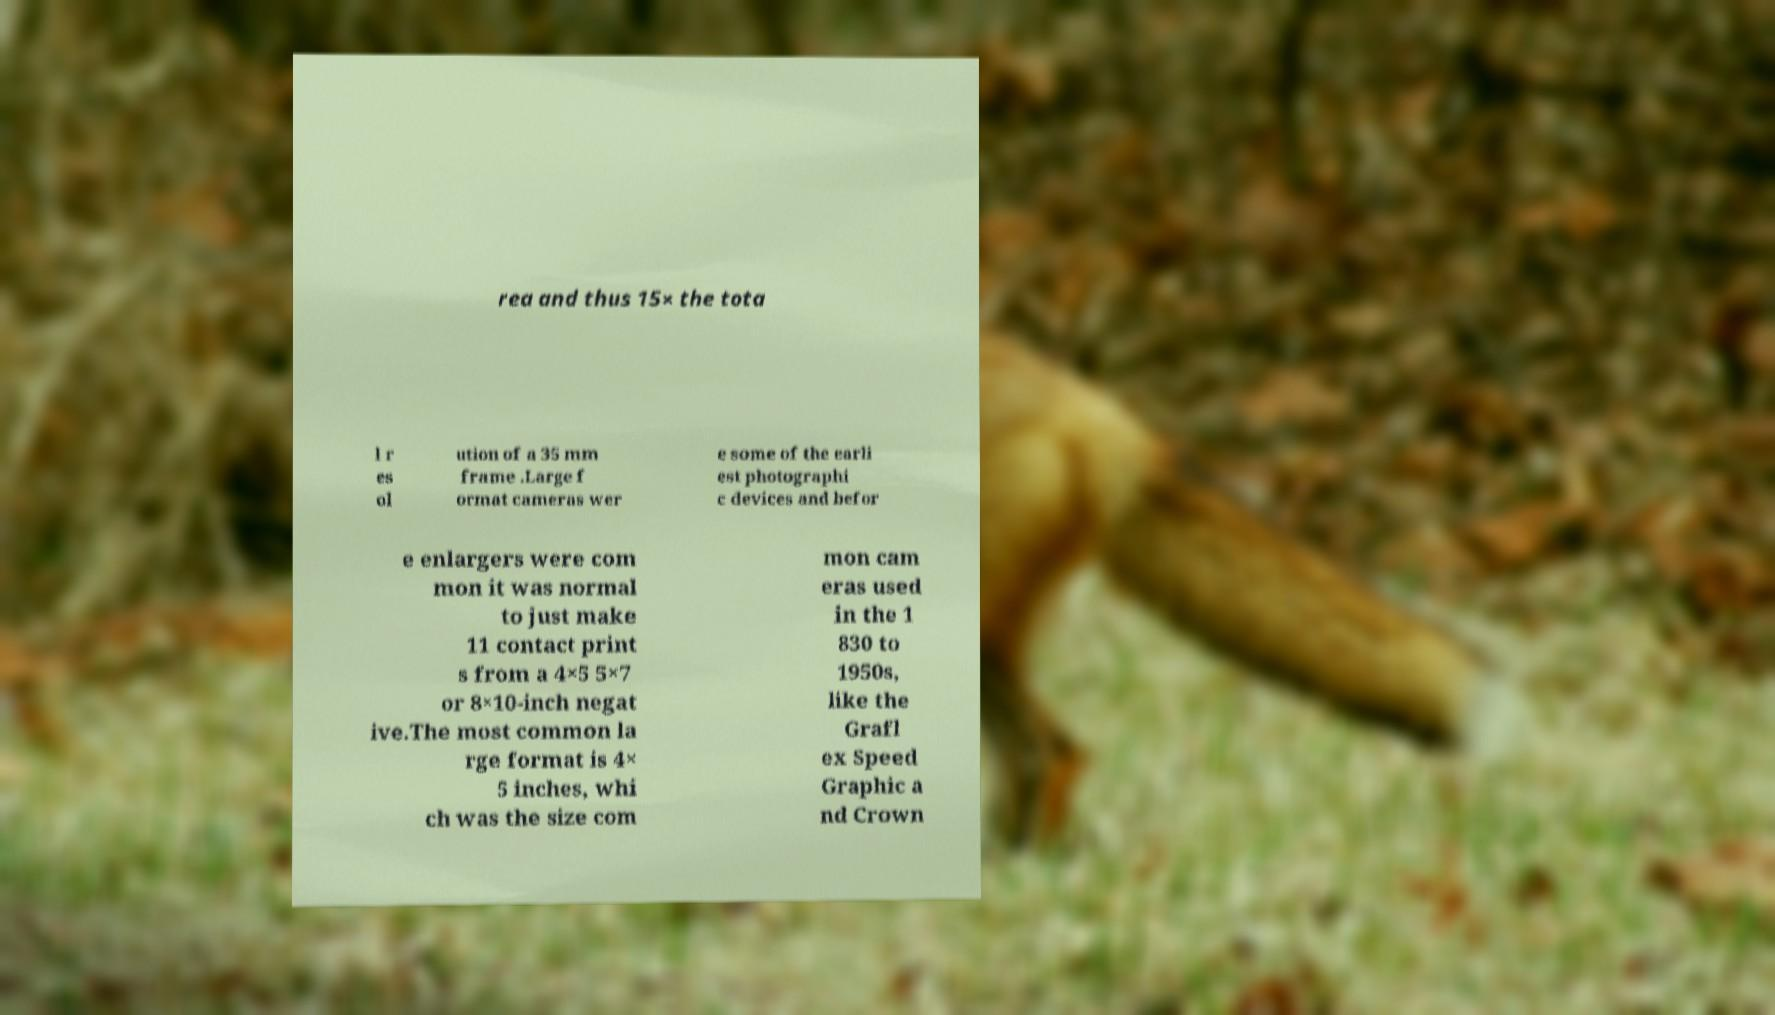Please identify and transcribe the text found in this image. rea and thus 15× the tota l r es ol ution of a 35 mm frame .Large f ormat cameras wer e some of the earli est photographi c devices and befor e enlargers were com mon it was normal to just make 11 contact print s from a 4×5 5×7 or 8×10-inch negat ive.The most common la rge format is 4× 5 inches, whi ch was the size com mon cam eras used in the 1 830 to 1950s, like the Grafl ex Speed Graphic a nd Crown 